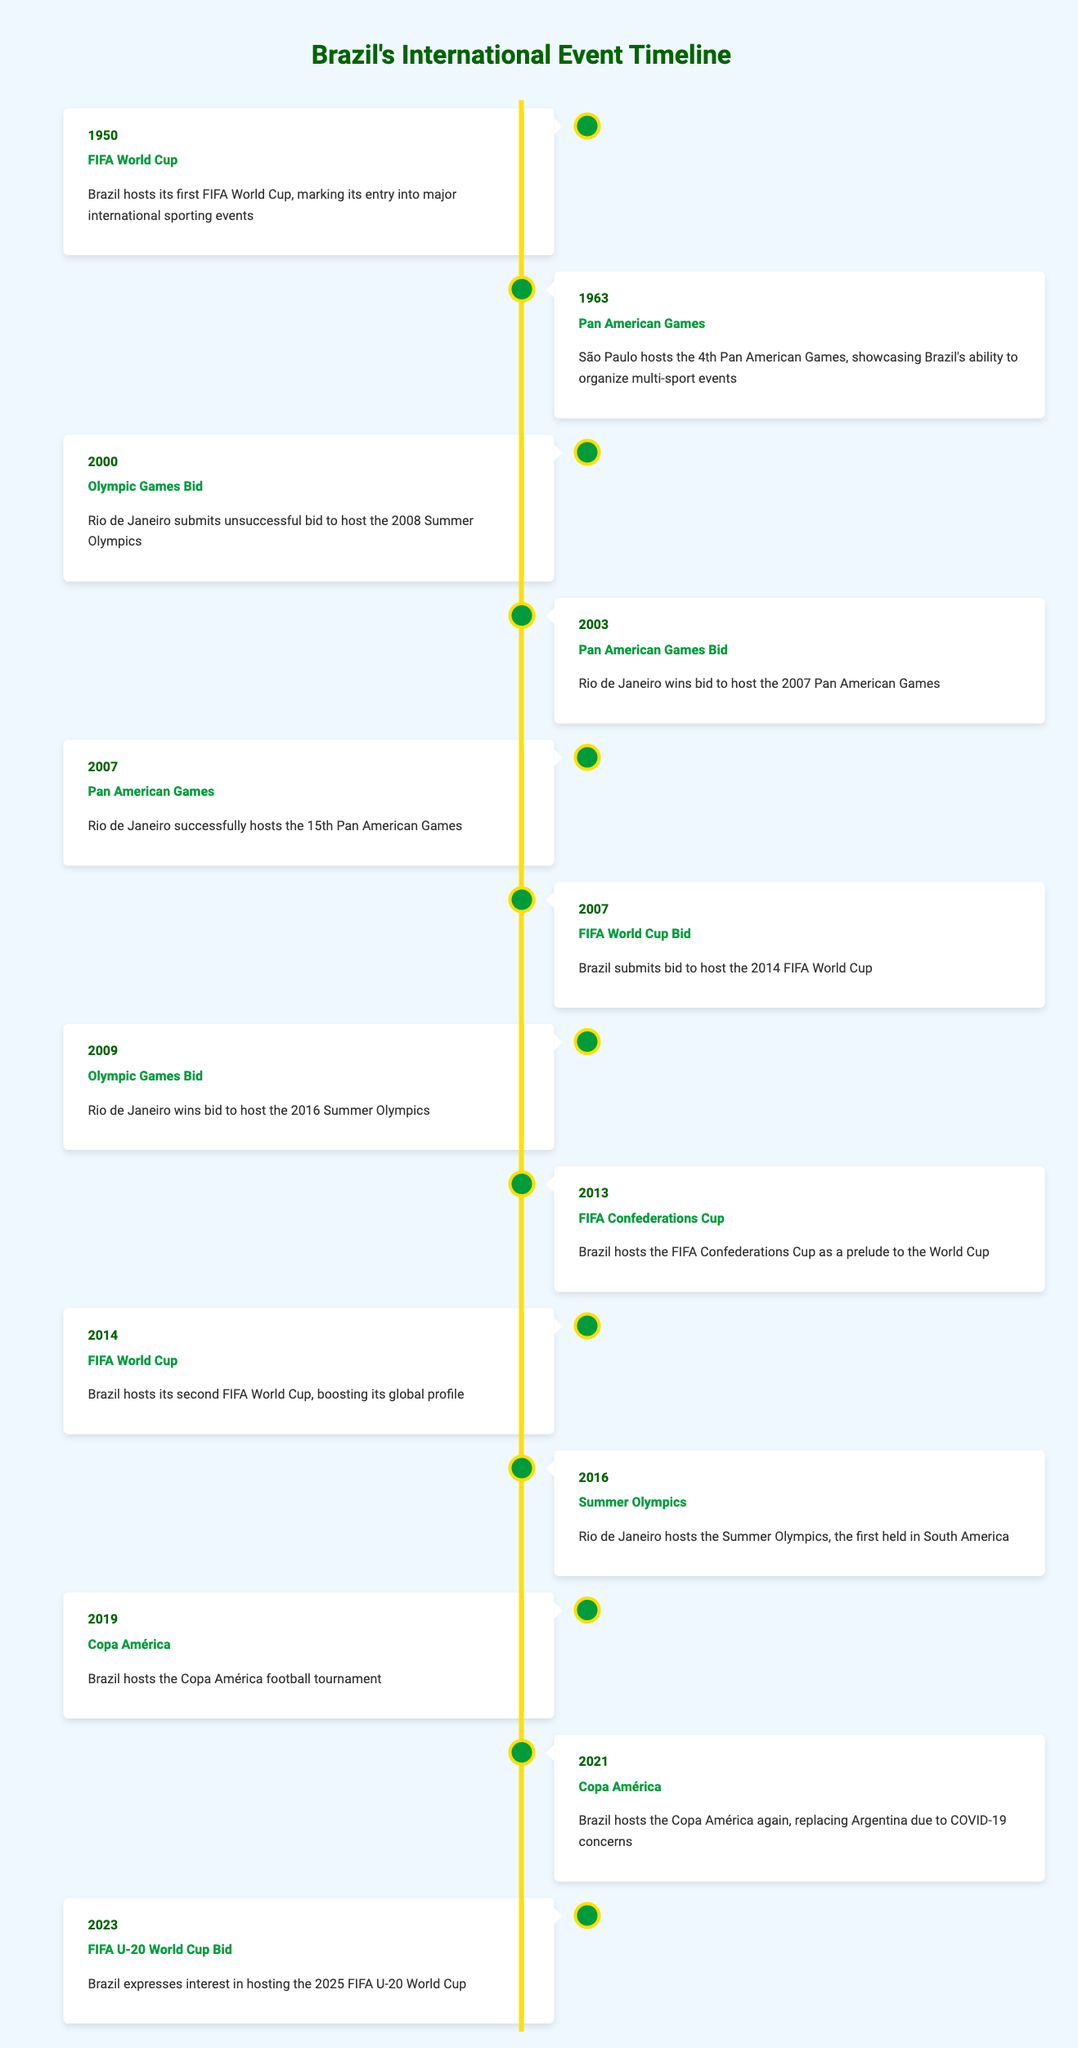What international sporting event did Brazil first host? The table indicates that Brazil hosted its first FIFA World Cup in 1950. This is the earliest event listed, establishing Brazil's involvement in major international sporting events.
Answer: FIFA World Cup In what year did São Paulo host the Pan American Games? According to the table, São Paulo hosted the 4th Pan American Games in 1963. This information is directly stated in the entry for that year.
Answer: 1963 Did Brazil submit a bid to host the 2008 Summer Olympics? The table shows that Rio de Janeiro submitted an unsuccessful bid in 2000 for the 2008 Summer Olympics, indicating that Brazil did indeed make such a bid.
Answer: Yes How many times has Brazil hosted the FIFA World Cup as per the table? The table lists two entries for the FIFA World Cup: one in 1950 and another in 2014. Adding these gives the total number of times Brazil has hosted this event.
Answer: 2 What is the difference in years between Brazil's first FIFA World Cup and the Summer Olympics hosted in Rio de Janeiro? The first FIFA World Cup was hosted in 1950, and Rio de Janeiro hosted the Summer Olympics in 2016. The difference between these two years is 2016 - 1950 = 66 years.
Answer: 66 years Which events did Brazil host in 2007? The table shows that Brazil hosted both the 15th Pan American Games and submitted a bid for the 2014 FIFA World Cup in 2007. Thus, the answer must include both events flagged for this year.
Answer: Pan American Games, FIFA World Cup Bid Is it true that Brazil hosted the Copa América more than once? According to the table, Brazil hosted the Copa América in 2019 and then again in 2021, confirming that this assertion is correct.
Answer: Yes What was the last international event Brazil expressed interest in hosting? The last entry in the table indicates that Brazil expressed interest in hosting the 2025 FIFA U-20 World Cup in 2023, signifying this as the most recent event listed.
Answer: FIFA U-20 World Cup Bid Calculate the total number of major international events Brazil hosted, according to the data. By reviewing the table, the events hosted include the FIFA World Cup (2), Pan American Games (2), FIFA Confederations Cup (1), Summer Olympics (1), and Copa América (2), totaling 8 events.
Answer: 8 